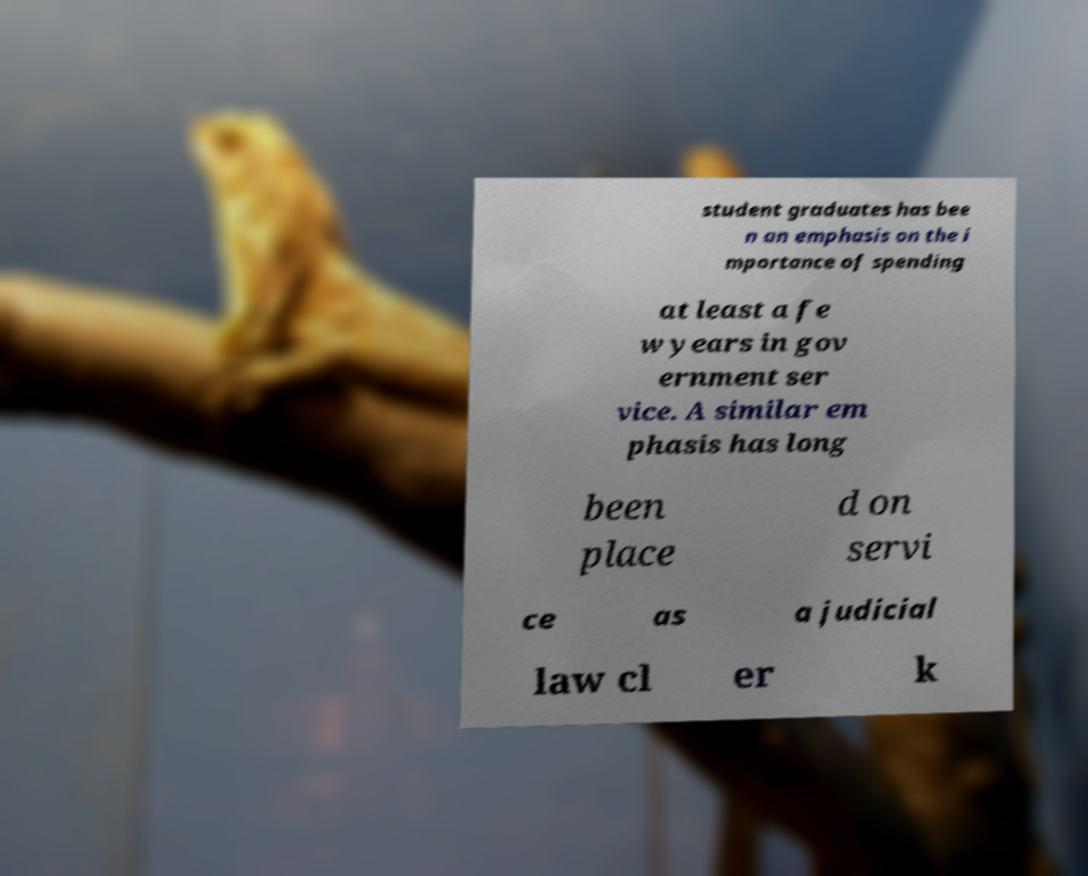For documentation purposes, I need the text within this image transcribed. Could you provide that? student graduates has bee n an emphasis on the i mportance of spending at least a fe w years in gov ernment ser vice. A similar em phasis has long been place d on servi ce as a judicial law cl er k 